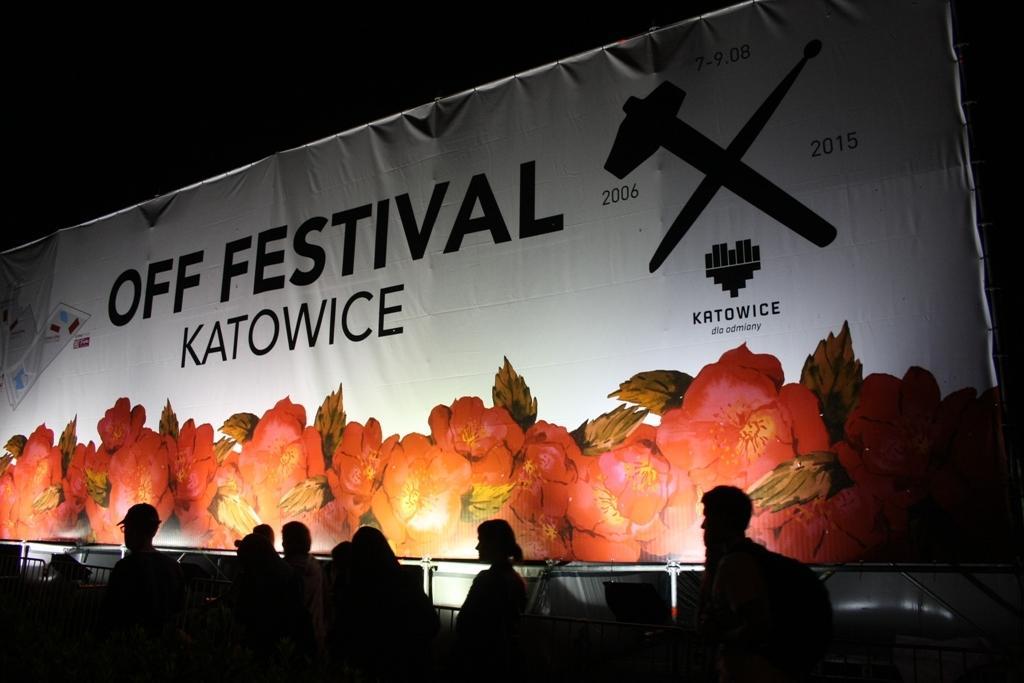Can you describe this image briefly? In this image, we can see some people. There is a banner in the middle of the image. 